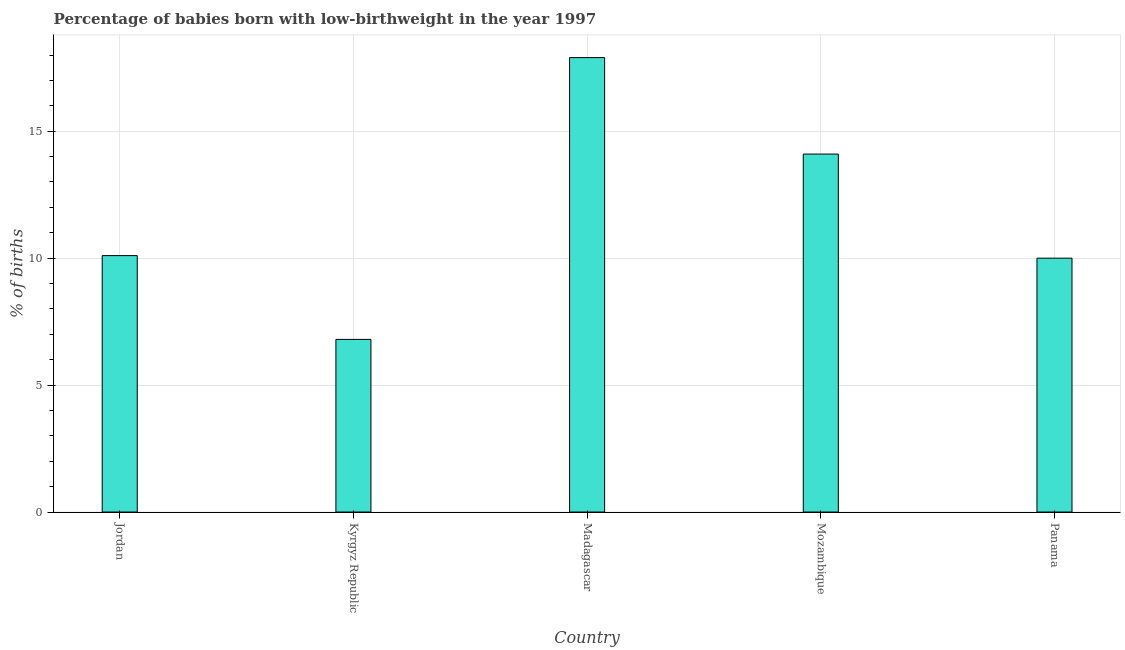What is the title of the graph?
Offer a very short reply. Percentage of babies born with low-birthweight in the year 1997. What is the label or title of the X-axis?
Offer a very short reply. Country. What is the label or title of the Y-axis?
Provide a succinct answer. % of births. What is the percentage of babies who were born with low-birthweight in Panama?
Your response must be concise. 10. Across all countries, what is the minimum percentage of babies who were born with low-birthweight?
Provide a succinct answer. 6.8. In which country was the percentage of babies who were born with low-birthweight maximum?
Your response must be concise. Madagascar. In which country was the percentage of babies who were born with low-birthweight minimum?
Offer a terse response. Kyrgyz Republic. What is the sum of the percentage of babies who were born with low-birthweight?
Offer a very short reply. 58.9. What is the average percentage of babies who were born with low-birthweight per country?
Your response must be concise. 11.78. What is the median percentage of babies who were born with low-birthweight?
Give a very brief answer. 10.1. In how many countries, is the percentage of babies who were born with low-birthweight greater than 10 %?
Make the answer very short. 3. What is the ratio of the percentage of babies who were born with low-birthweight in Jordan to that in Kyrgyz Republic?
Make the answer very short. 1.49. Is the difference between the percentage of babies who were born with low-birthweight in Kyrgyz Republic and Panama greater than the difference between any two countries?
Your answer should be compact. No. What is the difference between the highest and the second highest percentage of babies who were born with low-birthweight?
Your answer should be compact. 3.8. In how many countries, is the percentage of babies who were born with low-birthweight greater than the average percentage of babies who were born with low-birthweight taken over all countries?
Provide a short and direct response. 2. Are all the bars in the graph horizontal?
Your response must be concise. No. What is the % of births in Mozambique?
Offer a terse response. 14.1. What is the % of births in Panama?
Keep it short and to the point. 10. What is the difference between the % of births in Jordan and Kyrgyz Republic?
Ensure brevity in your answer.  3.3. What is the difference between the % of births in Jordan and Panama?
Keep it short and to the point. 0.1. What is the difference between the % of births in Kyrgyz Republic and Mozambique?
Give a very brief answer. -7.3. What is the difference between the % of births in Madagascar and Mozambique?
Offer a terse response. 3.8. What is the difference between the % of births in Mozambique and Panama?
Offer a very short reply. 4.1. What is the ratio of the % of births in Jordan to that in Kyrgyz Republic?
Keep it short and to the point. 1.49. What is the ratio of the % of births in Jordan to that in Madagascar?
Provide a succinct answer. 0.56. What is the ratio of the % of births in Jordan to that in Mozambique?
Offer a very short reply. 0.72. What is the ratio of the % of births in Kyrgyz Republic to that in Madagascar?
Give a very brief answer. 0.38. What is the ratio of the % of births in Kyrgyz Republic to that in Mozambique?
Keep it short and to the point. 0.48. What is the ratio of the % of births in Kyrgyz Republic to that in Panama?
Keep it short and to the point. 0.68. What is the ratio of the % of births in Madagascar to that in Mozambique?
Ensure brevity in your answer.  1.27. What is the ratio of the % of births in Madagascar to that in Panama?
Ensure brevity in your answer.  1.79. What is the ratio of the % of births in Mozambique to that in Panama?
Provide a short and direct response. 1.41. 